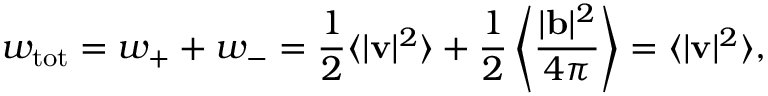<formula> <loc_0><loc_0><loc_500><loc_500>w _ { t o t } = w _ { + } + w _ { - } = \frac { 1 } { 2 } \langle | { v } | ^ { 2 } \rangle + \frac { 1 } { 2 } \left \langle \frac { | { b } | ^ { 2 } } { 4 \pi } \right \rangle = \langle | { v } | ^ { 2 } \rangle ,</formula> 